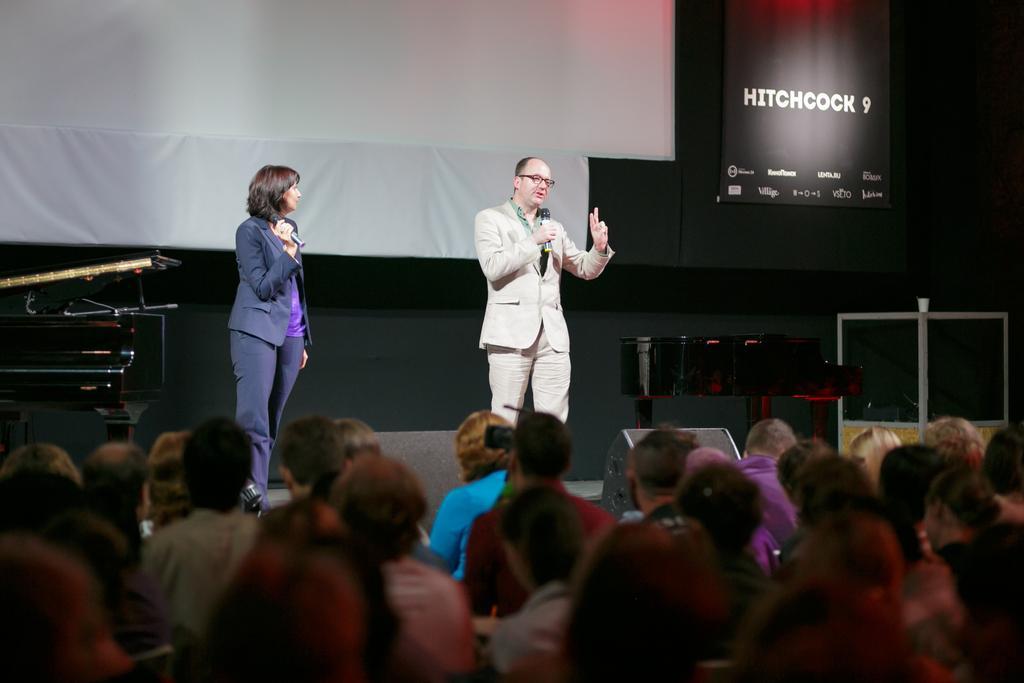Describe this image in one or two sentences. In this picture, we can see a group of people sitting and two people are standing and holding the microphones on the stage and the man is explaining something. Behind the people there are some objects, projector screen and a black banner. 